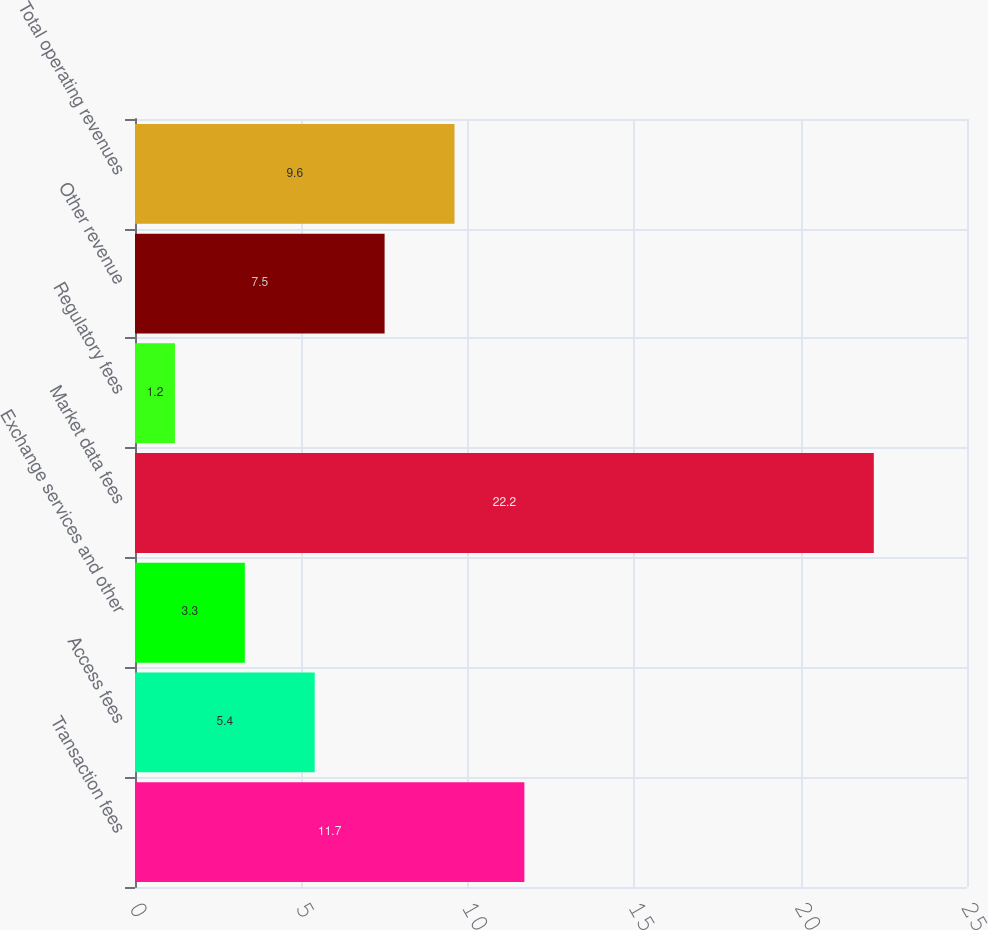Convert chart. <chart><loc_0><loc_0><loc_500><loc_500><bar_chart><fcel>Transaction fees<fcel>Access fees<fcel>Exchange services and other<fcel>Market data fees<fcel>Regulatory fees<fcel>Other revenue<fcel>Total operating revenues<nl><fcel>11.7<fcel>5.4<fcel>3.3<fcel>22.2<fcel>1.2<fcel>7.5<fcel>9.6<nl></chart> 